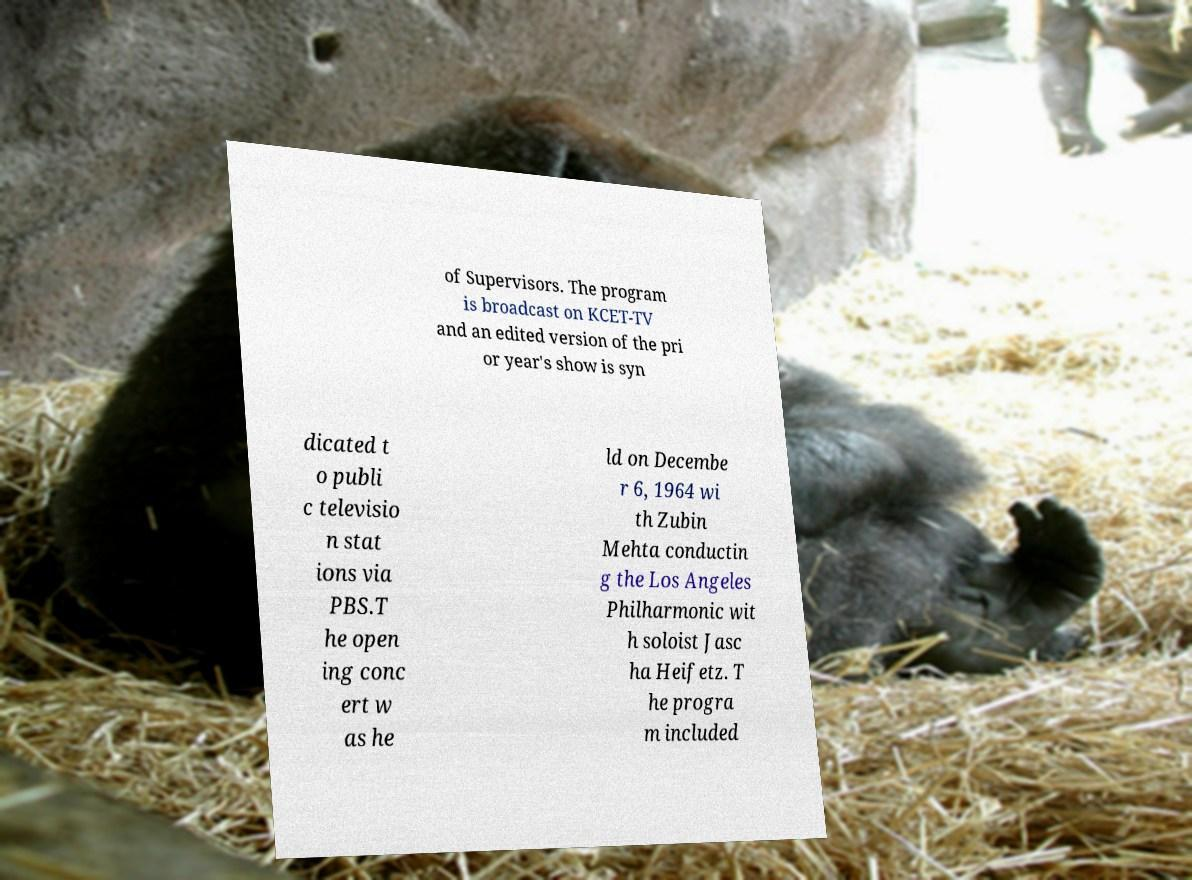For documentation purposes, I need the text within this image transcribed. Could you provide that? of Supervisors. The program is broadcast on KCET-TV and an edited version of the pri or year's show is syn dicated t o publi c televisio n stat ions via PBS.T he open ing conc ert w as he ld on Decembe r 6, 1964 wi th Zubin Mehta conductin g the Los Angeles Philharmonic wit h soloist Jasc ha Heifetz. T he progra m included 